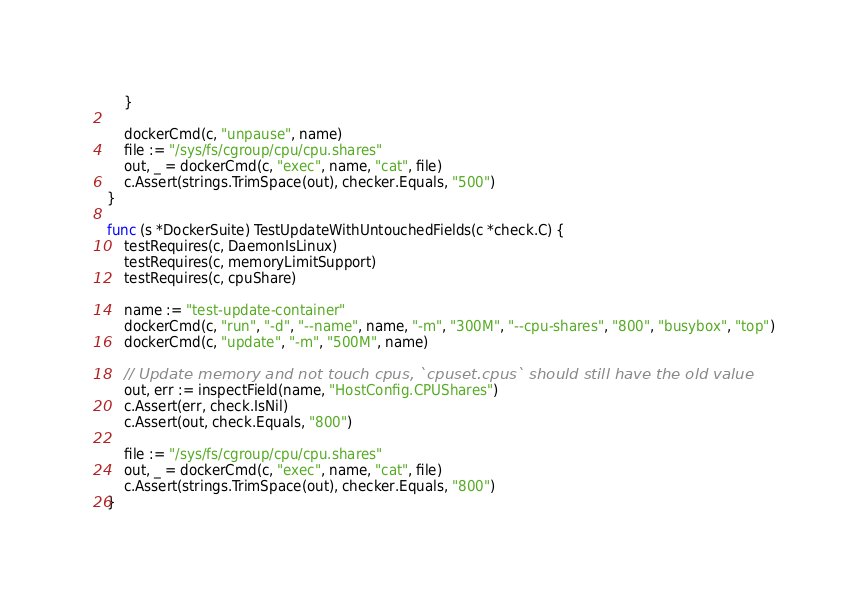Convert code to text. <code><loc_0><loc_0><loc_500><loc_500><_Go_>	}

	dockerCmd(c, "unpause", name)
	file := "/sys/fs/cgroup/cpu/cpu.shares"
	out, _ = dockerCmd(c, "exec", name, "cat", file)
	c.Assert(strings.TrimSpace(out), checker.Equals, "500")
}

func (s *DockerSuite) TestUpdateWithUntouchedFields(c *check.C) {
	testRequires(c, DaemonIsLinux)
	testRequires(c, memoryLimitSupport)
	testRequires(c, cpuShare)

	name := "test-update-container"
	dockerCmd(c, "run", "-d", "--name", name, "-m", "300M", "--cpu-shares", "800", "busybox", "top")
	dockerCmd(c, "update", "-m", "500M", name)

	// Update memory and not touch cpus, `cpuset.cpus` should still have the old value
	out, err := inspectField(name, "HostConfig.CPUShares")
	c.Assert(err, check.IsNil)
	c.Assert(out, check.Equals, "800")

	file := "/sys/fs/cgroup/cpu/cpu.shares"
	out, _ = dockerCmd(c, "exec", name, "cat", file)
	c.Assert(strings.TrimSpace(out), checker.Equals, "800")
}
</code> 